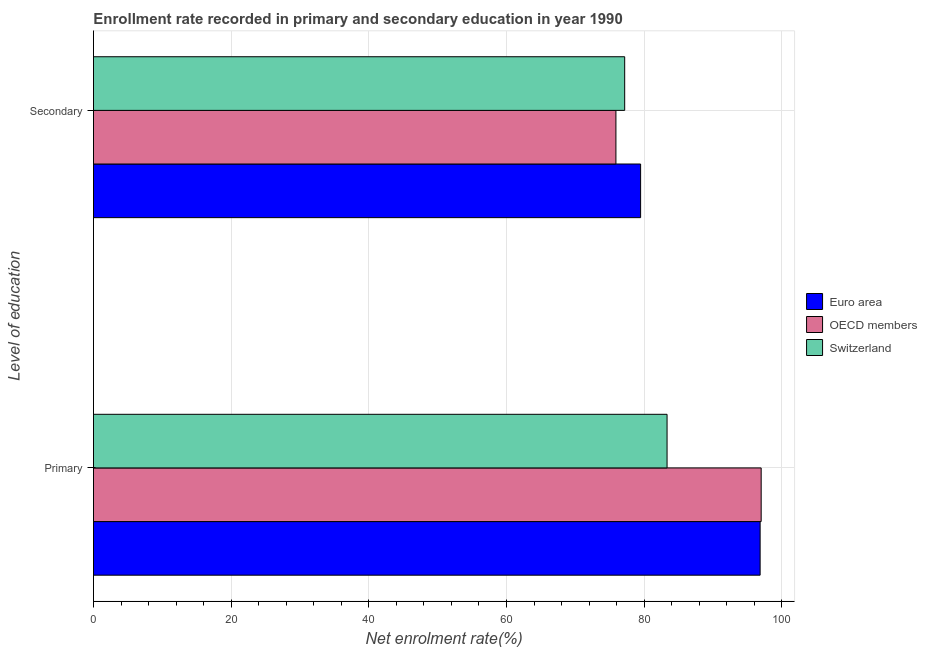How many different coloured bars are there?
Provide a short and direct response. 3. How many groups of bars are there?
Your answer should be compact. 2. Are the number of bars per tick equal to the number of legend labels?
Give a very brief answer. Yes. How many bars are there on the 2nd tick from the bottom?
Your answer should be compact. 3. What is the label of the 1st group of bars from the top?
Make the answer very short. Secondary. What is the enrollment rate in secondary education in OECD members?
Give a very brief answer. 75.89. Across all countries, what is the maximum enrollment rate in secondary education?
Provide a succinct answer. 79.48. Across all countries, what is the minimum enrollment rate in secondary education?
Offer a terse response. 75.89. In which country was the enrollment rate in primary education minimum?
Your response must be concise. Switzerland. What is the total enrollment rate in secondary education in the graph?
Provide a short and direct response. 232.54. What is the difference between the enrollment rate in secondary education in Euro area and that in OECD members?
Keep it short and to the point. 3.59. What is the difference between the enrollment rate in primary education in Switzerland and the enrollment rate in secondary education in Euro area?
Give a very brief answer. 3.84. What is the average enrollment rate in primary education per country?
Your response must be concise. 92.39. What is the difference between the enrollment rate in primary education and enrollment rate in secondary education in OECD members?
Your response must be concise. 21.1. What is the ratio of the enrollment rate in secondary education in Euro area to that in OECD members?
Keep it short and to the point. 1.05. What does the 2nd bar from the top in Primary represents?
Ensure brevity in your answer.  OECD members. Are all the bars in the graph horizontal?
Ensure brevity in your answer.  Yes. What is the difference between two consecutive major ticks on the X-axis?
Your answer should be compact. 20. Does the graph contain grids?
Your response must be concise. Yes. How many legend labels are there?
Offer a very short reply. 3. How are the legend labels stacked?
Your response must be concise. Vertical. What is the title of the graph?
Ensure brevity in your answer.  Enrollment rate recorded in primary and secondary education in year 1990. What is the label or title of the X-axis?
Give a very brief answer. Net enrolment rate(%). What is the label or title of the Y-axis?
Give a very brief answer. Level of education. What is the Net enrolment rate(%) of Euro area in Primary?
Ensure brevity in your answer.  96.84. What is the Net enrolment rate(%) in OECD members in Primary?
Offer a terse response. 96.99. What is the Net enrolment rate(%) in Switzerland in Primary?
Make the answer very short. 83.32. What is the Net enrolment rate(%) of Euro area in Secondary?
Keep it short and to the point. 79.48. What is the Net enrolment rate(%) in OECD members in Secondary?
Offer a very short reply. 75.89. What is the Net enrolment rate(%) in Switzerland in Secondary?
Ensure brevity in your answer.  77.17. Across all Level of education, what is the maximum Net enrolment rate(%) in Euro area?
Provide a short and direct response. 96.84. Across all Level of education, what is the maximum Net enrolment rate(%) in OECD members?
Keep it short and to the point. 96.99. Across all Level of education, what is the maximum Net enrolment rate(%) of Switzerland?
Your response must be concise. 83.32. Across all Level of education, what is the minimum Net enrolment rate(%) in Euro area?
Provide a succinct answer. 79.48. Across all Level of education, what is the minimum Net enrolment rate(%) of OECD members?
Your answer should be very brief. 75.89. Across all Level of education, what is the minimum Net enrolment rate(%) of Switzerland?
Ensure brevity in your answer.  77.17. What is the total Net enrolment rate(%) of Euro area in the graph?
Make the answer very short. 176.32. What is the total Net enrolment rate(%) in OECD members in the graph?
Make the answer very short. 172.89. What is the total Net enrolment rate(%) in Switzerland in the graph?
Provide a short and direct response. 160.49. What is the difference between the Net enrolment rate(%) of Euro area in Primary and that in Secondary?
Make the answer very short. 17.36. What is the difference between the Net enrolment rate(%) in OECD members in Primary and that in Secondary?
Keep it short and to the point. 21.1. What is the difference between the Net enrolment rate(%) in Switzerland in Primary and that in Secondary?
Your answer should be very brief. 6.16. What is the difference between the Net enrolment rate(%) of Euro area in Primary and the Net enrolment rate(%) of OECD members in Secondary?
Ensure brevity in your answer.  20.95. What is the difference between the Net enrolment rate(%) in Euro area in Primary and the Net enrolment rate(%) in Switzerland in Secondary?
Give a very brief answer. 19.67. What is the difference between the Net enrolment rate(%) in OECD members in Primary and the Net enrolment rate(%) in Switzerland in Secondary?
Keep it short and to the point. 19.83. What is the average Net enrolment rate(%) in Euro area per Level of education?
Your response must be concise. 88.16. What is the average Net enrolment rate(%) in OECD members per Level of education?
Your response must be concise. 86.44. What is the average Net enrolment rate(%) in Switzerland per Level of education?
Give a very brief answer. 80.25. What is the difference between the Net enrolment rate(%) in Euro area and Net enrolment rate(%) in OECD members in Primary?
Keep it short and to the point. -0.15. What is the difference between the Net enrolment rate(%) of Euro area and Net enrolment rate(%) of Switzerland in Primary?
Provide a succinct answer. 13.52. What is the difference between the Net enrolment rate(%) in OECD members and Net enrolment rate(%) in Switzerland in Primary?
Your answer should be compact. 13.67. What is the difference between the Net enrolment rate(%) in Euro area and Net enrolment rate(%) in OECD members in Secondary?
Provide a short and direct response. 3.59. What is the difference between the Net enrolment rate(%) in Euro area and Net enrolment rate(%) in Switzerland in Secondary?
Ensure brevity in your answer.  2.31. What is the difference between the Net enrolment rate(%) of OECD members and Net enrolment rate(%) of Switzerland in Secondary?
Offer a very short reply. -1.27. What is the ratio of the Net enrolment rate(%) of Euro area in Primary to that in Secondary?
Offer a very short reply. 1.22. What is the ratio of the Net enrolment rate(%) of OECD members in Primary to that in Secondary?
Offer a terse response. 1.28. What is the ratio of the Net enrolment rate(%) of Switzerland in Primary to that in Secondary?
Make the answer very short. 1.08. What is the difference between the highest and the second highest Net enrolment rate(%) of Euro area?
Your answer should be very brief. 17.36. What is the difference between the highest and the second highest Net enrolment rate(%) in OECD members?
Make the answer very short. 21.1. What is the difference between the highest and the second highest Net enrolment rate(%) in Switzerland?
Your answer should be very brief. 6.16. What is the difference between the highest and the lowest Net enrolment rate(%) of Euro area?
Offer a terse response. 17.36. What is the difference between the highest and the lowest Net enrolment rate(%) of OECD members?
Offer a terse response. 21.1. What is the difference between the highest and the lowest Net enrolment rate(%) in Switzerland?
Ensure brevity in your answer.  6.16. 